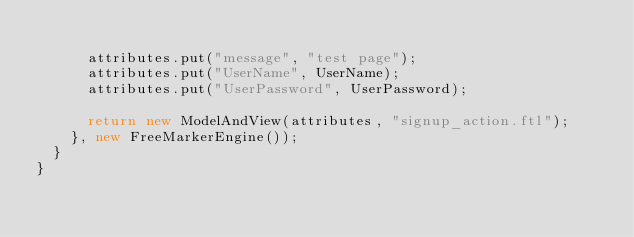<code> <loc_0><loc_0><loc_500><loc_500><_Java_>			
			attributes.put("message", "test page");
			attributes.put("UserName", UserName);
			attributes.put("UserPassword", UserPassword);
			
			return new ModelAndView(attributes, "signup_action.ftl");
		}, new FreeMarkerEngine());
	}
}
</code> 